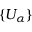<formula> <loc_0><loc_0><loc_500><loc_500>\{ U _ { \alpha } \}</formula> 